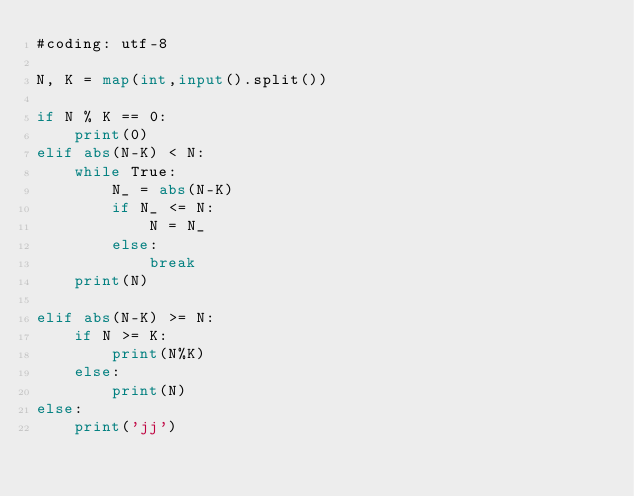Convert code to text. <code><loc_0><loc_0><loc_500><loc_500><_Python_>#coding: utf-8

N, K = map(int,input().split())

if N % K == 0:
    print(0)
elif abs(N-K) < N:
    while True:
        N_ = abs(N-K)
        if N_ <= N:
            N = N_
        else:
            break
    print(N)

elif abs(N-K) >= N:
    if N >= K:
        print(N%K)
    else:
        print(N)
else:
    print('jj')</code> 